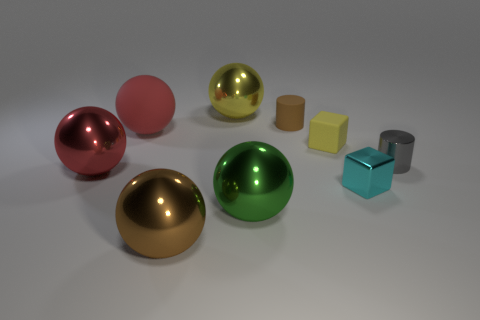Subtract 2 balls. How many balls are left? 3 Subtract all green balls. How many balls are left? 4 Subtract all big brown balls. How many balls are left? 4 Subtract all purple spheres. Subtract all gray cubes. How many spheres are left? 5 Add 1 blue objects. How many objects exist? 10 Subtract all cubes. How many objects are left? 7 Subtract all cyan matte cubes. Subtract all red spheres. How many objects are left? 7 Add 3 large red matte balls. How many large red matte balls are left? 4 Add 3 big shiny things. How many big shiny things exist? 7 Subtract 0 green blocks. How many objects are left? 9 